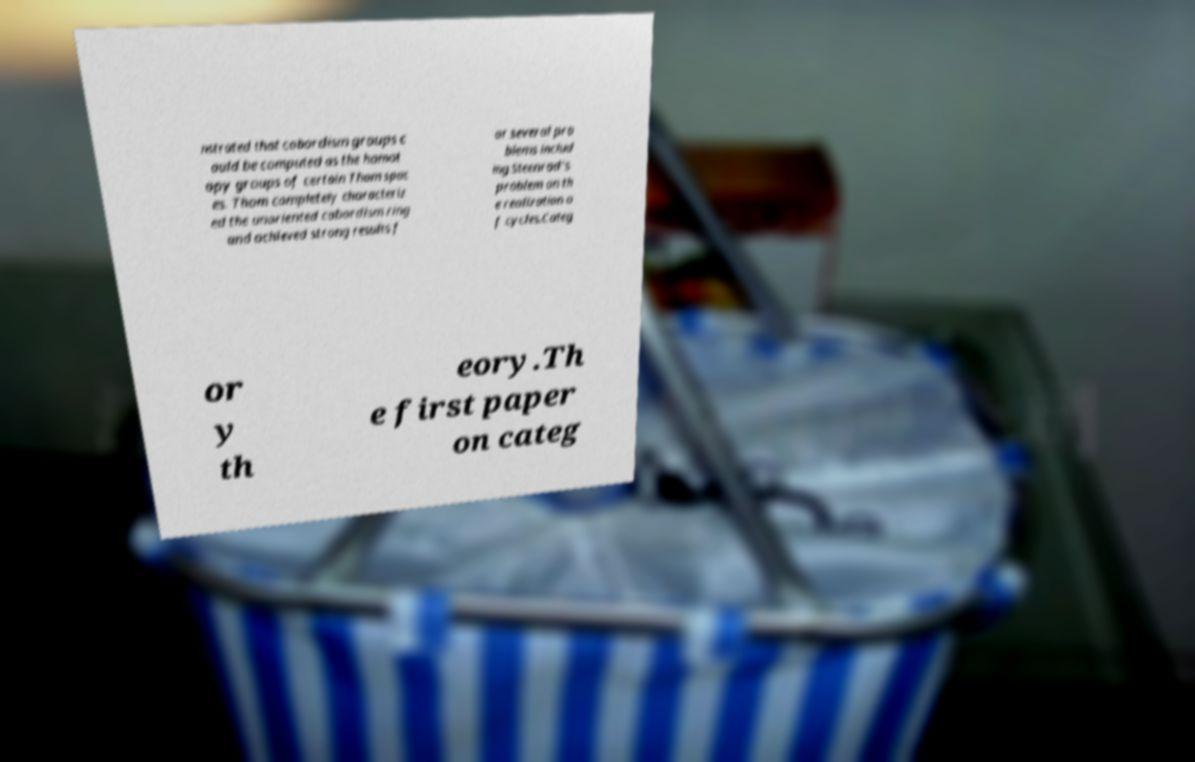Can you read and provide the text displayed in the image?This photo seems to have some interesting text. Can you extract and type it out for me? nstrated that cobordism groups c ould be computed as the homot opy groups of certain Thom spac es. Thom completely characteriz ed the unoriented cobordism ring and achieved strong results f or several pro blems includ ing Steenrod's problem on th e realization o f cycles.Categ or y th eory.Th e first paper on categ 